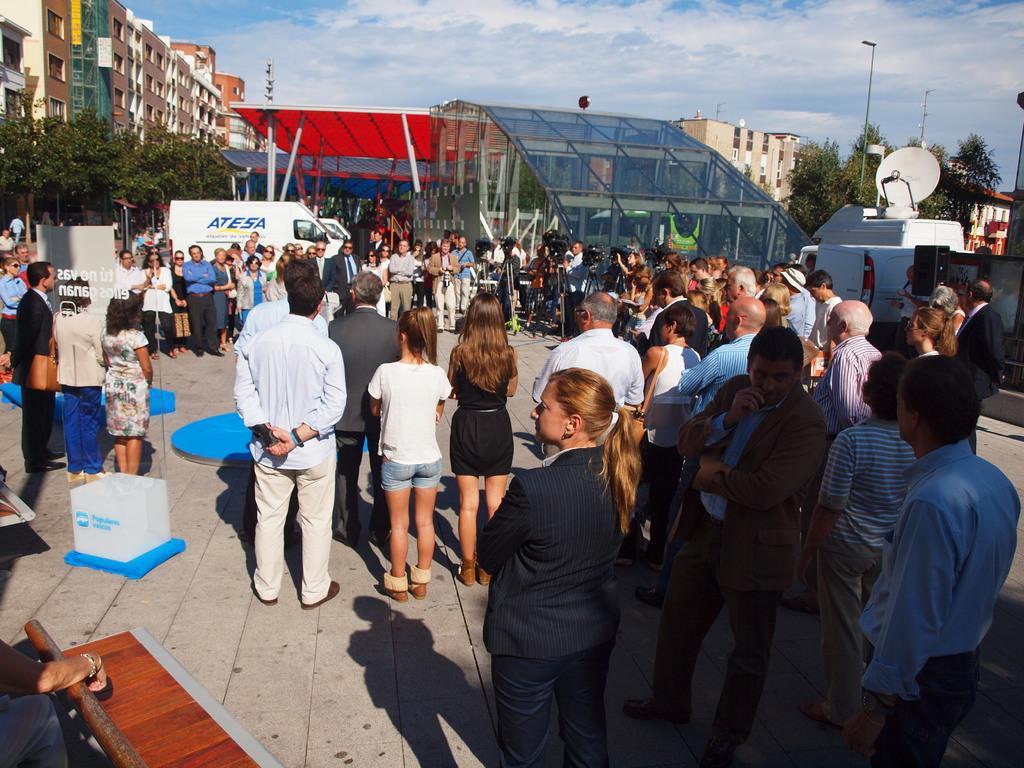Could you give a brief overview of what you see in this image? In front of the image there are people standing. There are vehicles and there are some objects on the road. In the background of the image there are buildings, trees, light poles. At the top of the image there are clouds in the sky. 